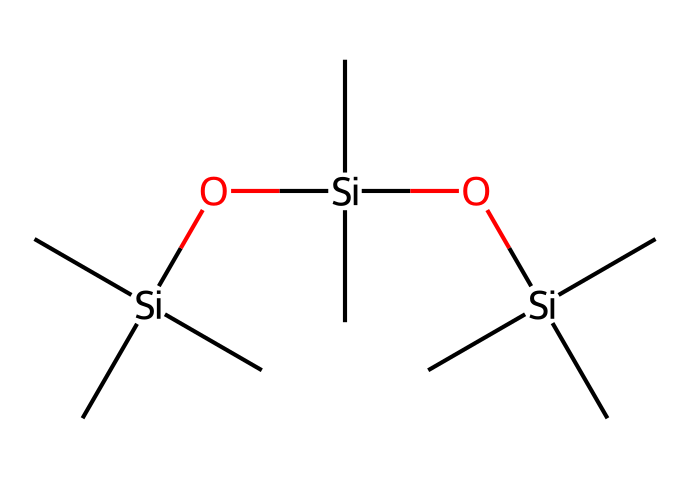How many silicon atoms are present in this chemical structure? The SMILES representation shows three occurrences of the 'Si' symbol, which indicates the presence of silicon atoms. Each 'Si' corresponds to one silicon atom.
Answer: three What functional groups are evident in this silane-based chemical? The chemical includes silanol groups (indicated by -O[Si]), where silicon is bonded to oxygen, and alkyl groups (indicated by -C), which are hydrocarbon chains.
Answer: silanol and alkyl groups What is the significance of the number of alkyl groups in this silane structure for water repellency? The presence of multiple alkyl groups increases the hydrophobic character of the compound, enhancing its water-repellent properties due to decreased polarity and increased non-polar character.
Answer: water-repellent How many oxygen atoms are there in the chemical structure? The 'O' characters in the SMILES indicate the presence of oxygen atoms, and there are two such occurrences, indicating two oxygen atoms in total.
Answer: two Explain the reason why this chemical will likely be effective as a water repellent for electronic devices. The presence of alkyl groups contributes to its hydrophobic nature, while the silanol groups can create strong chemical bonds with the surface of electronic devices, forming a protective layer that repels water. This combination helps prevent moisture damage to sensitive electronic components.
Answer: effective water repellent 